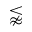<formula> <loc_0><loc_0><loc_500><loc_500>\lnapprox</formula> 